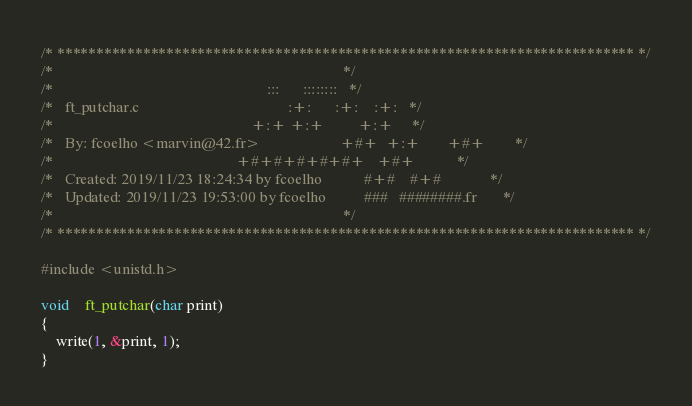<code> <loc_0><loc_0><loc_500><loc_500><_C_>/* ************************************************************************** */
/*                                                                            */
/*                                                        :::      ::::::::   */
/*   ft_putchar.c                                       :+:      :+:    :+:   */
/*                                                    +:+ +:+         +:+     */
/*   By: fcoelho <marvin@42.fr>                     +#+  +:+       +#+        */
/*                                                +#+#+#+#+#+   +#+           */
/*   Created: 2019/11/23 18:24:34 by fcoelho           #+#    #+#             */
/*   Updated: 2019/11/23 19:53:00 by fcoelho          ###   ########.fr       */
/*                                                                            */
/* ************************************************************************** */

#include <unistd.h>

void	ft_putchar(char print)
{
	write(1, &print, 1);
}
</code> 